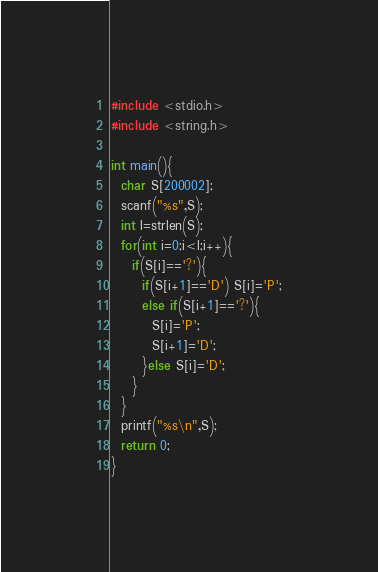<code> <loc_0><loc_0><loc_500><loc_500><_C_>#include <stdio.h>
#include <string.h>

int main(){
  char S[200002];
  scanf("%s",S);
  int l=strlen(S);
  for(int i=0;i<l;i++){
    if(S[i]=='?'){
      if(S[i+1]=='D') S[i]='P';
      else if(S[i+1]=='?'){
        S[i]='P';
        S[i+1]='D';
      }else S[i]='D';
    }
  }
  printf("%s\n",S);
  return 0;
}</code> 